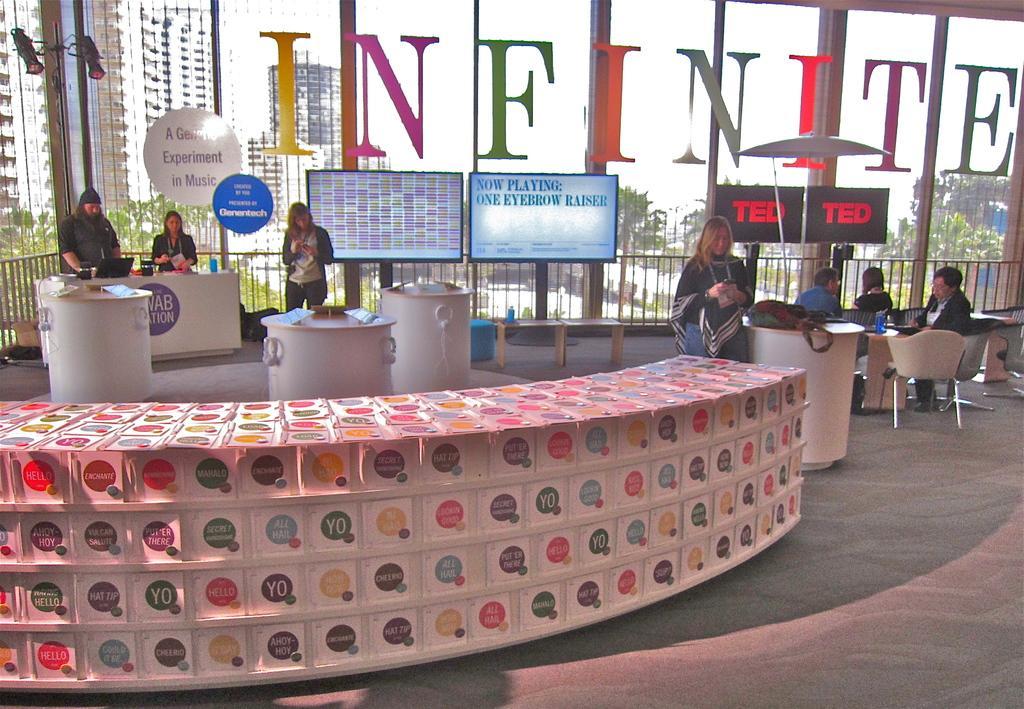Please provide a concise description of this image. In the center of the image we can see people standing and some of them are sitting. There are tables and chairs. In the background there are screens and we can see boards placed on the glass. 